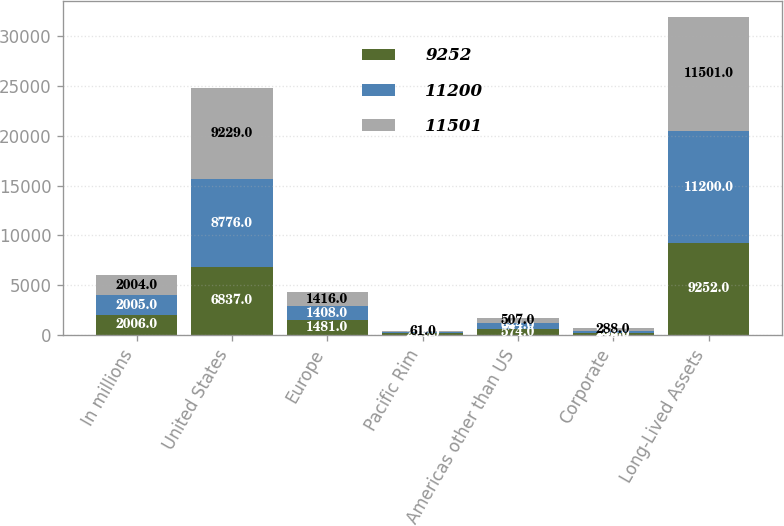<chart> <loc_0><loc_0><loc_500><loc_500><stacked_bar_chart><ecel><fcel>In millions<fcel>United States<fcel>Europe<fcel>Pacific Rim<fcel>Americas other than US<fcel>Corporate<fcel>Long-Lived Assets<nl><fcel>9252<fcel>2006<fcel>6837<fcel>1481<fcel>214<fcel>574<fcel>146<fcel>9252<nl><fcel>11200<fcel>2005<fcel>8776<fcel>1408<fcel>90<fcel>644<fcel>282<fcel>11200<nl><fcel>11501<fcel>2004<fcel>9229<fcel>1416<fcel>61<fcel>507<fcel>288<fcel>11501<nl></chart> 